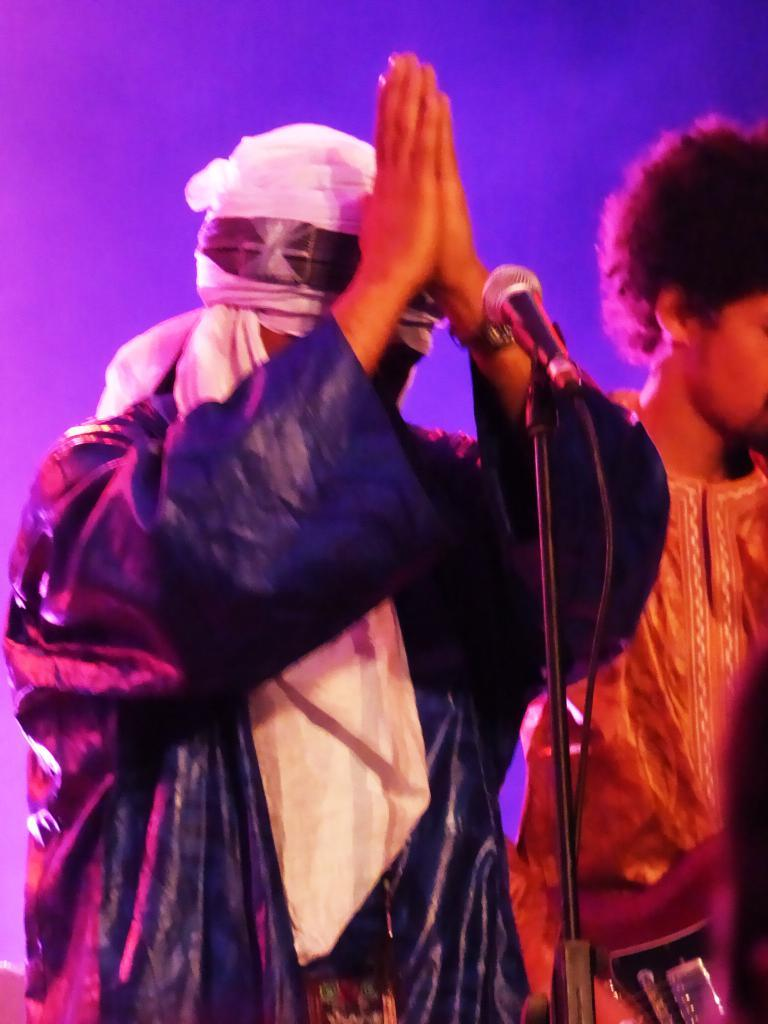How many people are in the image? There are two people standing in the image. What object can be seen in the image that is typically used for amplifying sound? There is a microphone in the image. What color is the background of the image? The background of the image is blue. What type of lettuce is being used as a prop in the image? There is no lettuce present in the image. How does the bread contribute to the overall theme of the image? There is no bread present in the image. 